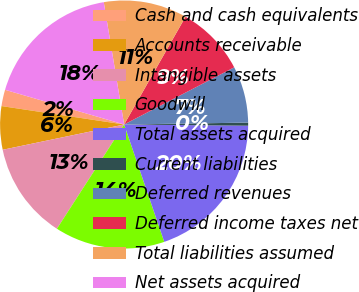<chart> <loc_0><loc_0><loc_500><loc_500><pie_chart><fcel>Cash and cash equivalents<fcel>Accounts receivable<fcel>Intangible assets<fcel>Goodwill<fcel>Total assets acquired<fcel>Current liabilities<fcel>Deferred revenues<fcel>Deferred income taxes net<fcel>Total liabilities assumed<fcel>Net assets acquired<nl><fcel>2.14%<fcel>5.64%<fcel>12.62%<fcel>14.36%<fcel>19.6%<fcel>0.4%<fcel>7.38%<fcel>9.13%<fcel>10.87%<fcel>17.86%<nl></chart> 